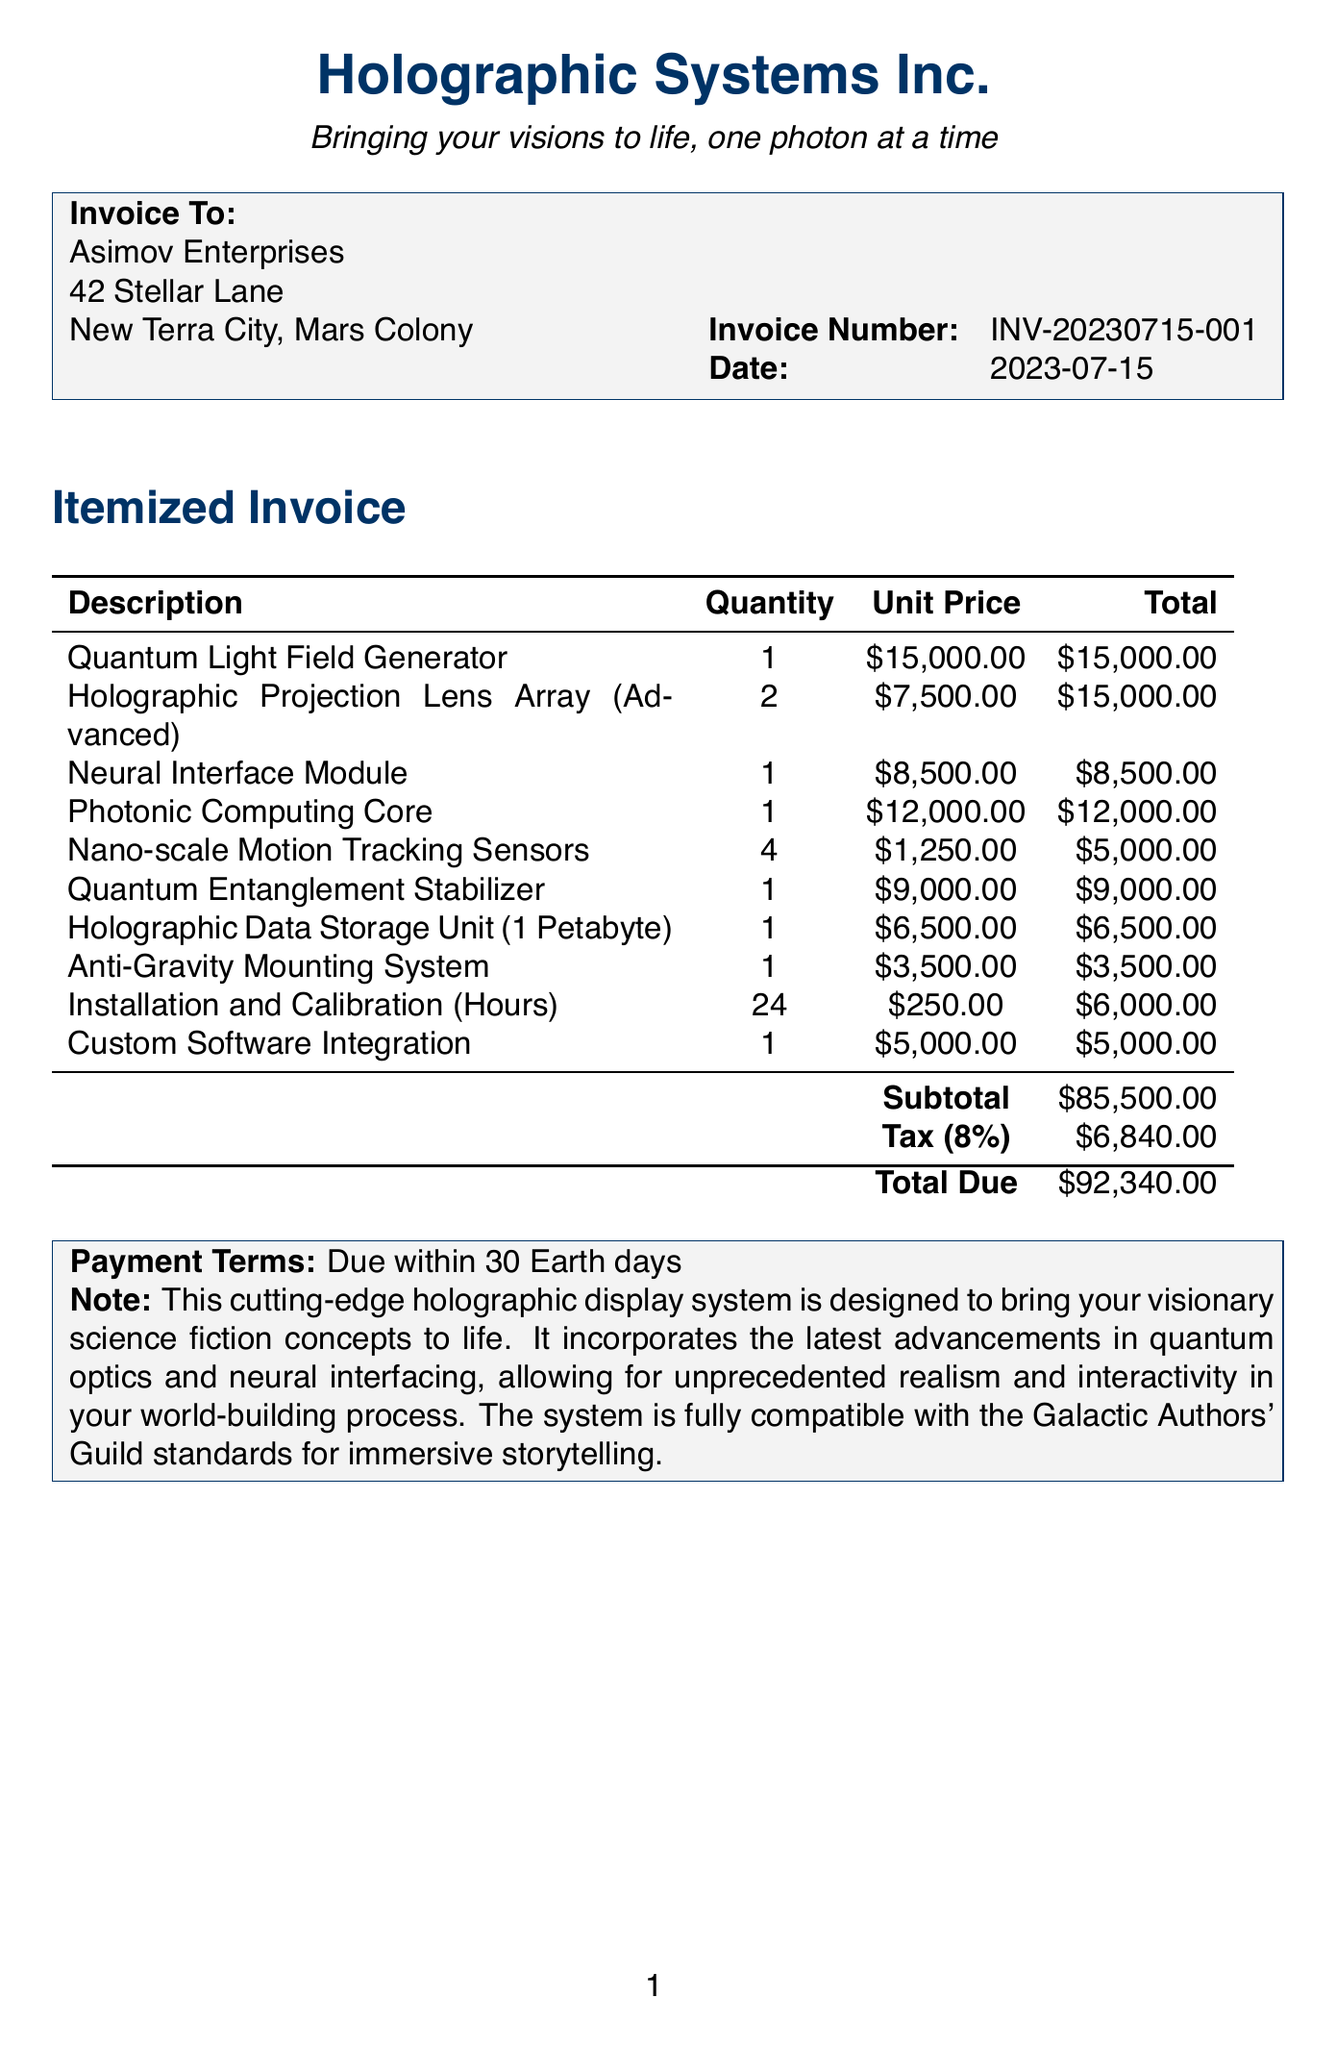What is the invoice number? The invoice number is given at the top of the document and identifies this specific transaction.
Answer: INV-20230715-001 What is the date of the invoice? The date is provided directly beneath the invoice number, indicating when the invoice was issued.
Answer: 2023-07-15 Who is the client? The client name is specified in the invoice header, representing the recipient of the services.
Answer: Asimov Enterprises What is the total due amount? The total due amount is calculated at the bottom of the invoice, representing the final payment required.
Answer: $92,340.00 How many Quantum Light Field Generators were sold? The quantity for each item is listed in the invoice, detailing how many of each component were purchased.
Answer: 1 What is the tax rate applied to the invoice? The tax rate is indicated in the invoice, which is a percentage applied to the subtotal to calculate the tax amount.
Answer: 8% What component has the highest unit price? By comparing the unit prices listed, we determine which item is the most expensive on the invoice.
Answer: Quantum Light Field Generator How many hours were billed for installation and calibration? The quantity of hours spent on installation is detailed next to that service description in the invoice.
Answer: 24 What is the subtotal amount before tax? The subtotal is listed in the invoice and represents the total before any tax is added.
Answer: $85,500.00 What note is included about the holographic display system? The note provides additional context about the system's purpose and capabilities as described in the document.
Answer: This cutting-edge holographic display system is designed to bring your visionary science fiction concepts to life 